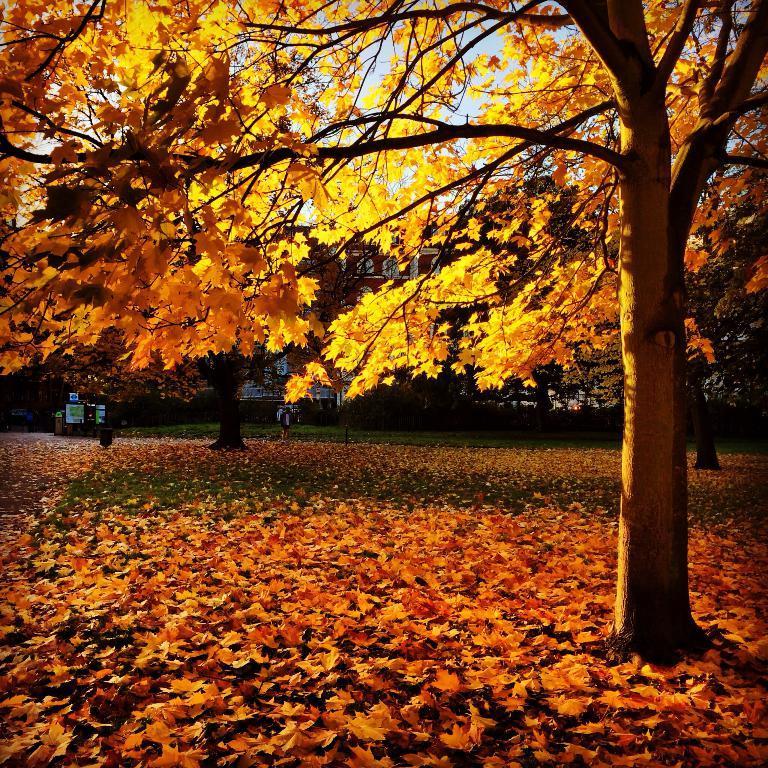Can you describe this image briefly? In this image we can see a group of trees and leaves on the ground. In the background we can see a building and the sky. 